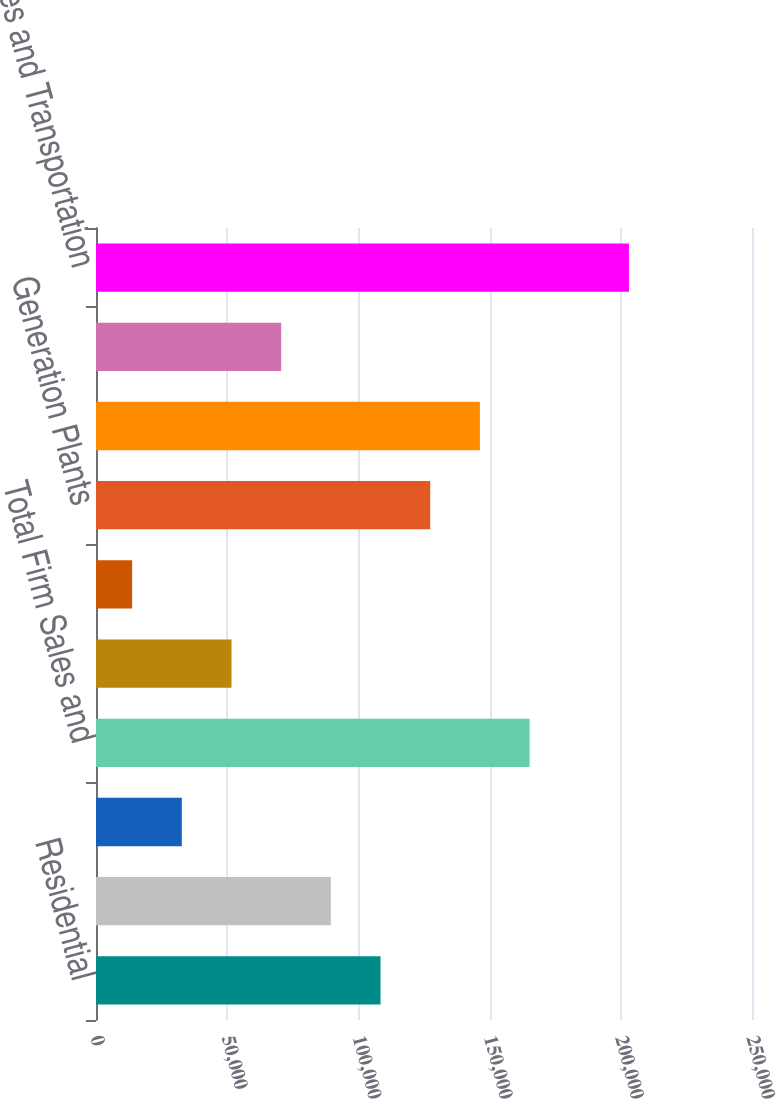Convert chart. <chart><loc_0><loc_0><loc_500><loc_500><bar_chart><fcel>Residential<fcel>General<fcel>Firm Transportation<fcel>Total Firm Sales and<fcel>Off Peak/ Interruptible Sales<fcel>NYPA<fcel>Generation Plants<fcel>Total NYPA and Generation<fcel>Other<fcel>Total Sales and Transportation<nl><fcel>108434<fcel>89499.6<fcel>32696.4<fcel>165237<fcel>51630.8<fcel>13762<fcel>127368<fcel>146303<fcel>70565.2<fcel>203106<nl></chart> 